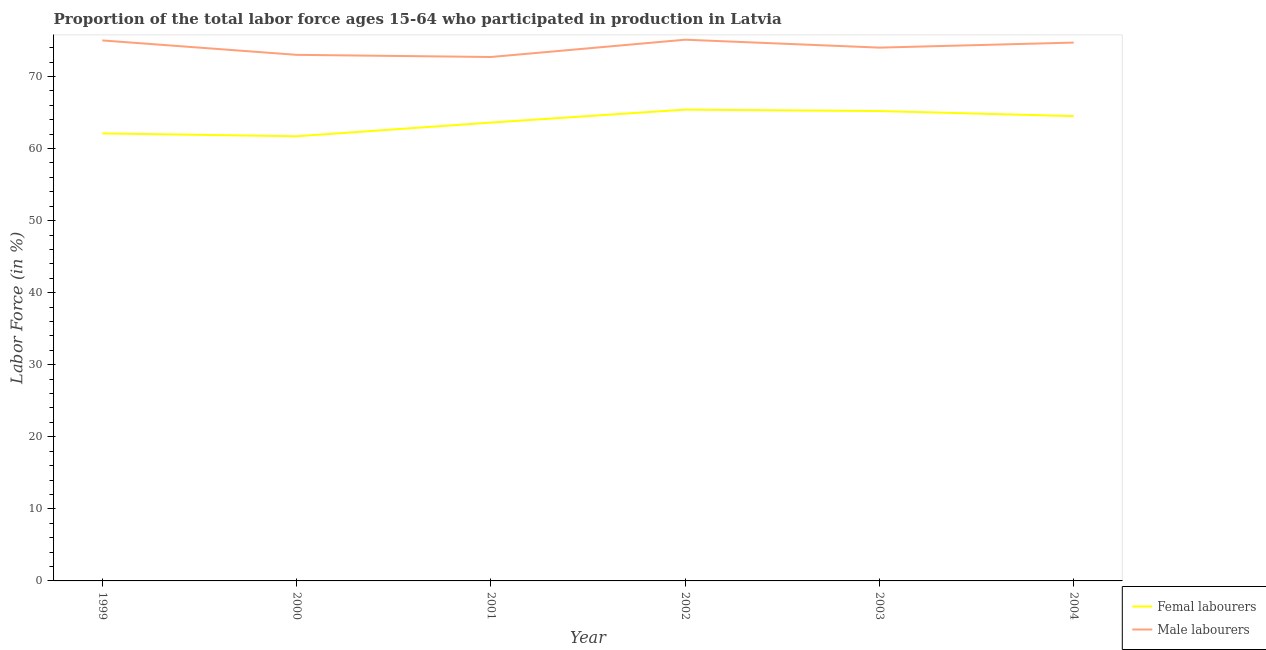How many different coloured lines are there?
Make the answer very short. 2. Does the line corresponding to percentage of male labour force intersect with the line corresponding to percentage of female labor force?
Provide a succinct answer. No. Is the number of lines equal to the number of legend labels?
Give a very brief answer. Yes. What is the percentage of male labour force in 2002?
Your answer should be compact. 75.1. Across all years, what is the maximum percentage of male labour force?
Offer a terse response. 75.1. Across all years, what is the minimum percentage of male labour force?
Ensure brevity in your answer.  72.7. What is the total percentage of male labour force in the graph?
Your answer should be very brief. 444.5. What is the difference between the percentage of female labor force in 2000 and that in 2002?
Offer a terse response. -3.7. What is the difference between the percentage of female labor force in 2004 and the percentage of male labour force in 2001?
Your response must be concise. -8.2. What is the average percentage of male labour force per year?
Keep it short and to the point. 74.08. In the year 1999, what is the difference between the percentage of female labor force and percentage of male labour force?
Provide a short and direct response. -12.9. In how many years, is the percentage of male labour force greater than 18 %?
Make the answer very short. 6. What is the ratio of the percentage of female labor force in 1999 to that in 2001?
Give a very brief answer. 0.98. Is the difference between the percentage of female labor force in 1999 and 2004 greater than the difference between the percentage of male labour force in 1999 and 2004?
Provide a short and direct response. No. What is the difference between the highest and the second highest percentage of male labour force?
Offer a very short reply. 0.1. What is the difference between the highest and the lowest percentage of female labor force?
Provide a succinct answer. 3.7. In how many years, is the percentage of female labor force greater than the average percentage of female labor force taken over all years?
Your response must be concise. 3. Does the percentage of female labor force monotonically increase over the years?
Offer a terse response. No. How many lines are there?
Your response must be concise. 2. What is the difference between two consecutive major ticks on the Y-axis?
Provide a succinct answer. 10. Are the values on the major ticks of Y-axis written in scientific E-notation?
Your answer should be very brief. No. Does the graph contain any zero values?
Make the answer very short. No. Does the graph contain grids?
Offer a very short reply. No. Where does the legend appear in the graph?
Ensure brevity in your answer.  Bottom right. How many legend labels are there?
Your answer should be very brief. 2. How are the legend labels stacked?
Keep it short and to the point. Vertical. What is the title of the graph?
Offer a very short reply. Proportion of the total labor force ages 15-64 who participated in production in Latvia. What is the Labor Force (in %) of Femal labourers in 1999?
Give a very brief answer. 62.1. What is the Labor Force (in %) in Femal labourers in 2000?
Ensure brevity in your answer.  61.7. What is the Labor Force (in %) of Male labourers in 2000?
Your response must be concise. 73. What is the Labor Force (in %) in Femal labourers in 2001?
Make the answer very short. 63.6. What is the Labor Force (in %) in Male labourers in 2001?
Your answer should be compact. 72.7. What is the Labor Force (in %) in Femal labourers in 2002?
Your response must be concise. 65.4. What is the Labor Force (in %) of Male labourers in 2002?
Offer a terse response. 75.1. What is the Labor Force (in %) of Femal labourers in 2003?
Ensure brevity in your answer.  65.2. What is the Labor Force (in %) of Male labourers in 2003?
Keep it short and to the point. 74. What is the Labor Force (in %) of Femal labourers in 2004?
Provide a succinct answer. 64.5. What is the Labor Force (in %) of Male labourers in 2004?
Give a very brief answer. 74.7. Across all years, what is the maximum Labor Force (in %) of Femal labourers?
Your answer should be compact. 65.4. Across all years, what is the maximum Labor Force (in %) in Male labourers?
Your answer should be very brief. 75.1. Across all years, what is the minimum Labor Force (in %) of Femal labourers?
Ensure brevity in your answer.  61.7. Across all years, what is the minimum Labor Force (in %) in Male labourers?
Your answer should be very brief. 72.7. What is the total Labor Force (in %) in Femal labourers in the graph?
Offer a terse response. 382.5. What is the total Labor Force (in %) in Male labourers in the graph?
Your answer should be very brief. 444.5. What is the difference between the Labor Force (in %) of Femal labourers in 1999 and that in 2000?
Your answer should be compact. 0.4. What is the difference between the Labor Force (in %) of Femal labourers in 1999 and that in 2003?
Provide a succinct answer. -3.1. What is the difference between the Labor Force (in %) of Femal labourers in 2000 and that in 2002?
Give a very brief answer. -3.7. What is the difference between the Labor Force (in %) of Male labourers in 2000 and that in 2002?
Your answer should be compact. -2.1. What is the difference between the Labor Force (in %) of Male labourers in 2000 and that in 2004?
Offer a terse response. -1.7. What is the difference between the Labor Force (in %) in Femal labourers in 2001 and that in 2003?
Offer a terse response. -1.6. What is the difference between the Labor Force (in %) in Femal labourers in 2001 and that in 2004?
Keep it short and to the point. -0.9. What is the difference between the Labor Force (in %) in Femal labourers in 2002 and that in 2003?
Keep it short and to the point. 0.2. What is the difference between the Labor Force (in %) in Male labourers in 2002 and that in 2003?
Offer a very short reply. 1.1. What is the difference between the Labor Force (in %) of Male labourers in 2003 and that in 2004?
Provide a short and direct response. -0.7. What is the difference between the Labor Force (in %) of Femal labourers in 1999 and the Labor Force (in %) of Male labourers in 2001?
Give a very brief answer. -10.6. What is the difference between the Labor Force (in %) in Femal labourers in 1999 and the Labor Force (in %) in Male labourers in 2003?
Provide a short and direct response. -11.9. What is the difference between the Labor Force (in %) of Femal labourers in 1999 and the Labor Force (in %) of Male labourers in 2004?
Offer a very short reply. -12.6. What is the difference between the Labor Force (in %) in Femal labourers in 2002 and the Labor Force (in %) in Male labourers in 2004?
Your response must be concise. -9.3. What is the average Labor Force (in %) of Femal labourers per year?
Give a very brief answer. 63.75. What is the average Labor Force (in %) in Male labourers per year?
Provide a succinct answer. 74.08. In the year 1999, what is the difference between the Labor Force (in %) of Femal labourers and Labor Force (in %) of Male labourers?
Your response must be concise. -12.9. In the year 2001, what is the difference between the Labor Force (in %) of Femal labourers and Labor Force (in %) of Male labourers?
Offer a very short reply. -9.1. In the year 2003, what is the difference between the Labor Force (in %) in Femal labourers and Labor Force (in %) in Male labourers?
Provide a short and direct response. -8.8. In the year 2004, what is the difference between the Labor Force (in %) in Femal labourers and Labor Force (in %) in Male labourers?
Make the answer very short. -10.2. What is the ratio of the Labor Force (in %) of Femal labourers in 1999 to that in 2000?
Your answer should be very brief. 1.01. What is the ratio of the Labor Force (in %) in Male labourers in 1999 to that in 2000?
Keep it short and to the point. 1.03. What is the ratio of the Labor Force (in %) of Femal labourers in 1999 to that in 2001?
Offer a very short reply. 0.98. What is the ratio of the Labor Force (in %) in Male labourers in 1999 to that in 2001?
Make the answer very short. 1.03. What is the ratio of the Labor Force (in %) of Femal labourers in 1999 to that in 2002?
Your answer should be compact. 0.95. What is the ratio of the Labor Force (in %) in Male labourers in 1999 to that in 2002?
Your answer should be very brief. 1. What is the ratio of the Labor Force (in %) of Femal labourers in 1999 to that in 2003?
Ensure brevity in your answer.  0.95. What is the ratio of the Labor Force (in %) of Male labourers in 1999 to that in 2003?
Make the answer very short. 1.01. What is the ratio of the Labor Force (in %) of Femal labourers in 1999 to that in 2004?
Provide a succinct answer. 0.96. What is the ratio of the Labor Force (in %) in Femal labourers in 2000 to that in 2001?
Ensure brevity in your answer.  0.97. What is the ratio of the Labor Force (in %) in Male labourers in 2000 to that in 2001?
Provide a succinct answer. 1. What is the ratio of the Labor Force (in %) of Femal labourers in 2000 to that in 2002?
Ensure brevity in your answer.  0.94. What is the ratio of the Labor Force (in %) in Male labourers in 2000 to that in 2002?
Your answer should be compact. 0.97. What is the ratio of the Labor Force (in %) in Femal labourers in 2000 to that in 2003?
Your answer should be very brief. 0.95. What is the ratio of the Labor Force (in %) of Male labourers in 2000 to that in 2003?
Ensure brevity in your answer.  0.99. What is the ratio of the Labor Force (in %) in Femal labourers in 2000 to that in 2004?
Offer a very short reply. 0.96. What is the ratio of the Labor Force (in %) in Male labourers in 2000 to that in 2004?
Your answer should be very brief. 0.98. What is the ratio of the Labor Force (in %) of Femal labourers in 2001 to that in 2002?
Keep it short and to the point. 0.97. What is the ratio of the Labor Force (in %) in Male labourers in 2001 to that in 2002?
Keep it short and to the point. 0.97. What is the ratio of the Labor Force (in %) in Femal labourers in 2001 to that in 2003?
Provide a short and direct response. 0.98. What is the ratio of the Labor Force (in %) of Male labourers in 2001 to that in 2003?
Give a very brief answer. 0.98. What is the ratio of the Labor Force (in %) in Male labourers in 2001 to that in 2004?
Provide a short and direct response. 0.97. What is the ratio of the Labor Force (in %) of Male labourers in 2002 to that in 2003?
Your answer should be compact. 1.01. What is the ratio of the Labor Force (in %) of Male labourers in 2002 to that in 2004?
Provide a succinct answer. 1.01. What is the ratio of the Labor Force (in %) in Femal labourers in 2003 to that in 2004?
Provide a succinct answer. 1.01. What is the ratio of the Labor Force (in %) in Male labourers in 2003 to that in 2004?
Your answer should be compact. 0.99. What is the difference between the highest and the second highest Labor Force (in %) in Male labourers?
Provide a succinct answer. 0.1. What is the difference between the highest and the lowest Labor Force (in %) in Femal labourers?
Your answer should be compact. 3.7. What is the difference between the highest and the lowest Labor Force (in %) in Male labourers?
Provide a succinct answer. 2.4. 